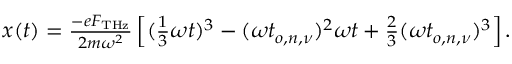<formula> <loc_0><loc_0><loc_500><loc_500>\begin{array} { r } { x ( t ) = \frac { - e F _ { T H z } } { 2 m \omega ^ { 2 } } \left [ ( \frac { 1 } { 3 } \omega t ) ^ { 3 } - ( \omega t _ { o , n , \nu } ) ^ { 2 } \omega t + \frac { 2 } { 3 } ( \omega t _ { o , n , \nu } ) ^ { 3 } \right ] . } \end{array}</formula> 